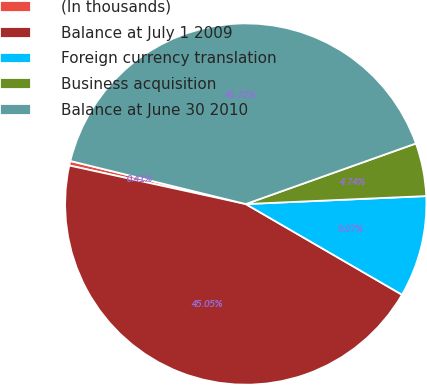<chart> <loc_0><loc_0><loc_500><loc_500><pie_chart><fcel>(In thousands)<fcel>Balance at July 1 2009<fcel>Foreign currency translation<fcel>Business acquisition<fcel>Balance at June 30 2010<nl><fcel>0.41%<fcel>45.05%<fcel>9.07%<fcel>4.74%<fcel>40.72%<nl></chart> 